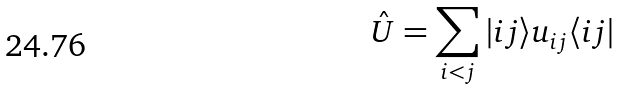Convert formula to latex. <formula><loc_0><loc_0><loc_500><loc_500>\hat { U } = \sum _ { i < j } | i j \rangle u _ { i j } \langle i j |</formula> 